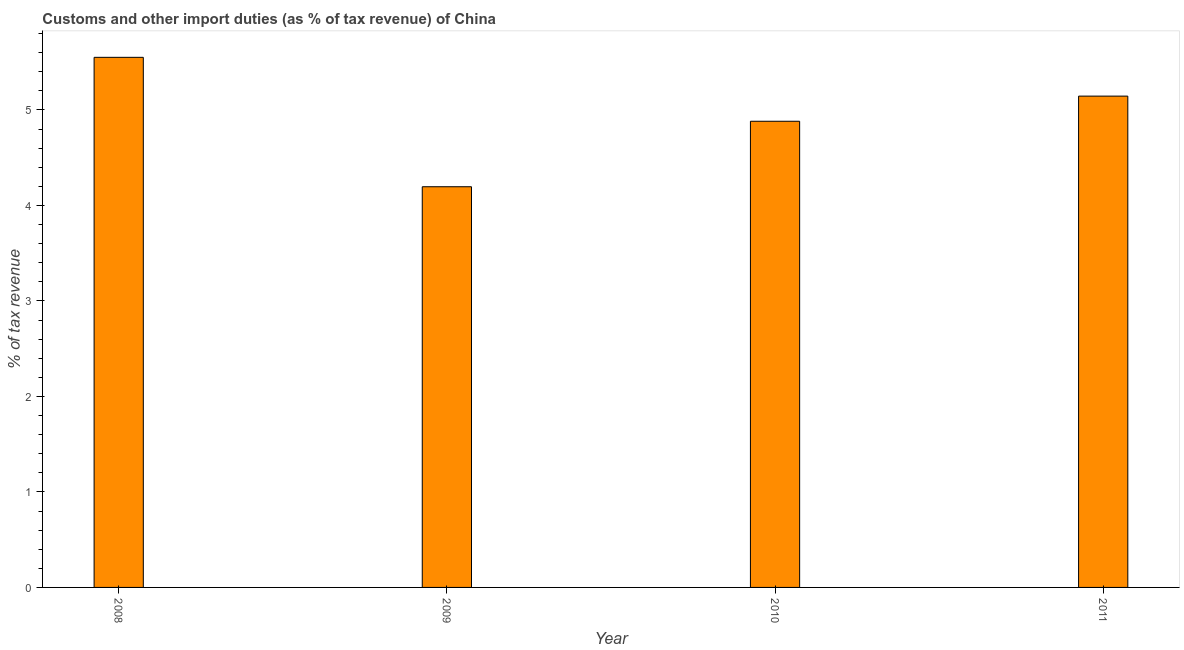What is the title of the graph?
Provide a short and direct response. Customs and other import duties (as % of tax revenue) of China. What is the label or title of the X-axis?
Ensure brevity in your answer.  Year. What is the label or title of the Y-axis?
Keep it short and to the point. % of tax revenue. What is the customs and other import duties in 2008?
Give a very brief answer. 5.55. Across all years, what is the maximum customs and other import duties?
Make the answer very short. 5.55. Across all years, what is the minimum customs and other import duties?
Give a very brief answer. 4.2. In which year was the customs and other import duties minimum?
Offer a terse response. 2009. What is the sum of the customs and other import duties?
Keep it short and to the point. 19.77. What is the difference between the customs and other import duties in 2009 and 2011?
Ensure brevity in your answer.  -0.95. What is the average customs and other import duties per year?
Offer a very short reply. 4.94. What is the median customs and other import duties?
Your answer should be compact. 5.01. In how many years, is the customs and other import duties greater than 1 %?
Your answer should be compact. 4. Do a majority of the years between 2011 and 2010 (inclusive) have customs and other import duties greater than 4.8 %?
Keep it short and to the point. No. What is the ratio of the customs and other import duties in 2008 to that in 2011?
Offer a terse response. 1.08. What is the difference between the highest and the second highest customs and other import duties?
Your response must be concise. 0.41. What is the difference between the highest and the lowest customs and other import duties?
Provide a succinct answer. 1.36. In how many years, is the customs and other import duties greater than the average customs and other import duties taken over all years?
Offer a very short reply. 2. How many bars are there?
Provide a succinct answer. 4. Are all the bars in the graph horizontal?
Provide a succinct answer. No. How many years are there in the graph?
Provide a succinct answer. 4. What is the difference between two consecutive major ticks on the Y-axis?
Provide a short and direct response. 1. Are the values on the major ticks of Y-axis written in scientific E-notation?
Offer a terse response. No. What is the % of tax revenue in 2008?
Offer a very short reply. 5.55. What is the % of tax revenue in 2009?
Make the answer very short. 4.2. What is the % of tax revenue of 2010?
Your answer should be compact. 4.88. What is the % of tax revenue of 2011?
Offer a terse response. 5.14. What is the difference between the % of tax revenue in 2008 and 2009?
Ensure brevity in your answer.  1.36. What is the difference between the % of tax revenue in 2008 and 2010?
Your answer should be compact. 0.67. What is the difference between the % of tax revenue in 2008 and 2011?
Provide a short and direct response. 0.41. What is the difference between the % of tax revenue in 2009 and 2010?
Give a very brief answer. -0.69. What is the difference between the % of tax revenue in 2009 and 2011?
Your answer should be compact. -0.95. What is the difference between the % of tax revenue in 2010 and 2011?
Keep it short and to the point. -0.26. What is the ratio of the % of tax revenue in 2008 to that in 2009?
Your response must be concise. 1.32. What is the ratio of the % of tax revenue in 2008 to that in 2010?
Your answer should be compact. 1.14. What is the ratio of the % of tax revenue in 2008 to that in 2011?
Your answer should be compact. 1.08. What is the ratio of the % of tax revenue in 2009 to that in 2010?
Your response must be concise. 0.86. What is the ratio of the % of tax revenue in 2009 to that in 2011?
Provide a short and direct response. 0.82. What is the ratio of the % of tax revenue in 2010 to that in 2011?
Offer a very short reply. 0.95. 